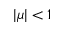<formula> <loc_0><loc_0><loc_500><loc_500>| \mu | < 1</formula> 